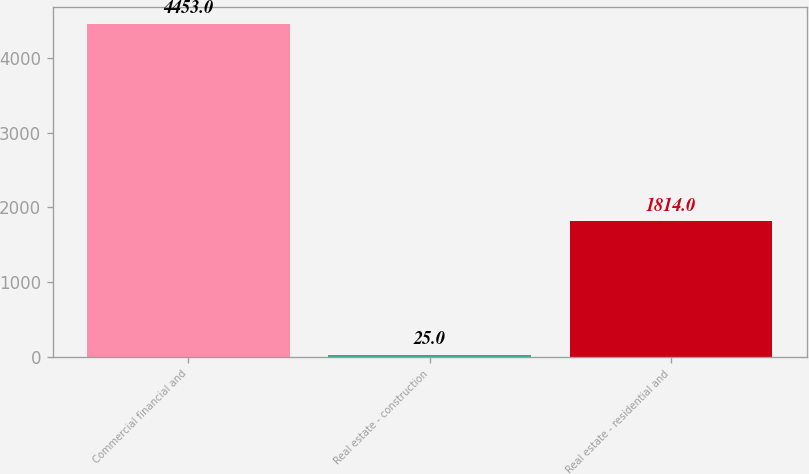<chart> <loc_0><loc_0><loc_500><loc_500><bar_chart><fcel>Commercial financial and<fcel>Real estate - construction<fcel>Real estate - residential and<nl><fcel>4453<fcel>25<fcel>1814<nl></chart> 